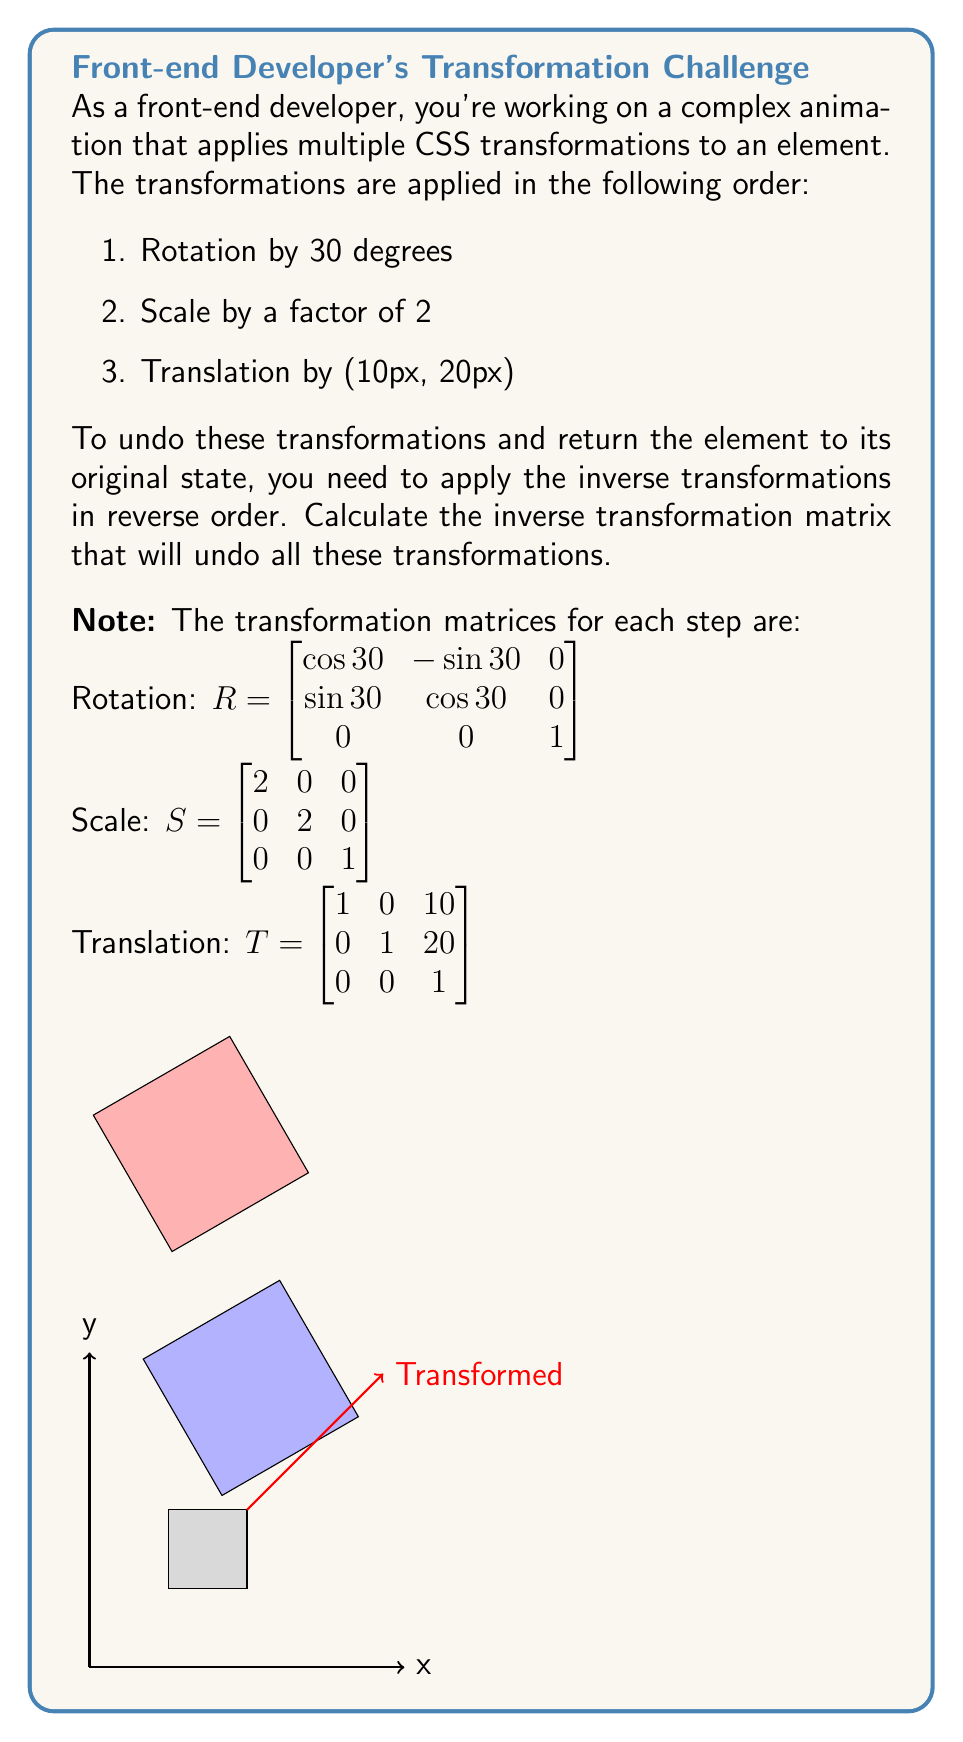Give your solution to this math problem. To solve this problem, we'll follow these steps:

1. Combine the transformation matrices
2. Calculate the inverse of the combined matrix

Step 1: Combine the transformation matrices

The combined transformation matrix is the product of the individual matrices in the order they were applied:

$$M = T \cdot S \cdot R$$

Let's calculate this step by step:

First, multiply S and R:

$$S \cdot R = \begin{bmatrix} 2 & 0 & 0 \\ 0 & 2 & 0 \\ 0 & 0 & 1 \end{bmatrix} \cdot \begin{bmatrix} \cos 30° & -\sin 30° & 0 \\ \sin 30° & \cos 30° & 0 \\ 0 & 0 & 1 \end{bmatrix}$$

$$= \begin{bmatrix} 2\cos 30° & -2\sin 30° & 0 \\ 2\sin 30° & 2\cos 30° & 0 \\ 0 & 0 & 1 \end{bmatrix}$$

Now, multiply T with the result:

$$M = T \cdot (S \cdot R) = \begin{bmatrix} 1 & 0 & 10 \\ 0 & 1 & 20 \\ 0 & 0 & 1 \end{bmatrix} \cdot \begin{bmatrix} 2\cos 30° & -2\sin 30° & 0 \\ 2\sin 30° & 2\cos 30° & 0 \\ 0 & 0 & 1 \end{bmatrix}$$

$$= \begin{bmatrix} 2\cos 30° & -2\sin 30° & 10 \\ 2\sin 30° & 2\cos 30° & 20 \\ 0 & 0 & 1 \end{bmatrix}$$

Step 2: Calculate the inverse of the combined matrix

To undo the transformations, we need to calculate $M^{-1}$. The inverse of a 3x3 matrix can be calculated using the adjugate method:

$$M^{-1} = \frac{1}{det(M)} \cdot adj(M)$$

Where $det(M)$ is the determinant of M and $adj(M)$ is the adjugate of M.

Calculating the determinant:

$$det(M) = 2\cos 30° \cdot 2\cos 30° \cdot 1 + (-2\sin 30°) \cdot 2\sin 30° \cdot 0 + 10 \cdot 20 \cdot 0 - 10 \cdot 2\cos 30° \cdot 0 - (-2\sin 30°) \cdot 20 \cdot 0 - 2\cos 30° \cdot 2\sin 30° \cdot 1$$

$$= 4\cos^2 30° - 4\sin^2 30° = 4(\cos^2 30° - \sin^2 30°) = 4 \cdot \frac{\sqrt{3}}{2} = 2\sqrt{3}$$

Now, let's calculate the adjugate matrix:

$$adj(M) = \begin{bmatrix} 
2\cos 30° & -2\sin 30° & -10\cos 30° + 20\sin 30° \\
2\sin 30° & 2\cos 30° & -10\sin 30° - 20\cos 30° \\
0 & 0 & 4\cos^2 30° + 4\sin^2 30°
\end{bmatrix}$$

Finally, we can calculate the inverse matrix:

$$M^{-1} = \frac{1}{2\sqrt{3}} \cdot \begin{bmatrix} 
2\cos 30° & -2\sin 30° & -10\cos 30° + 20\sin 30° \\
2\sin 30° & 2\cos 30° & -10\sin 30° - 20\cos 30° \\
0 & 0 & 4\cos^2 30° + 4\sin^2 30°
\end{bmatrix}$$

$$= \begin{bmatrix} 
\frac{\cos 30°}{\sqrt{3}} & -\frac{\sin 30°}{\sqrt{3}} & \frac{-5\cos 30° + 10\sin 30°}{\sqrt{3}} \\
\frac{\sin 30°}{\sqrt{3}} & \frac{\cos 30°}{\sqrt{3}} & \frac{-5\sin 30° - 10\cos 30°}{\sqrt{3}} \\
0 & 0 & \frac{1}{2}
\end{bmatrix}$$

This inverse matrix represents the transformation that will undo all the applied transformations and return the element to its original state.
Answer: $$M^{-1} = \begin{bmatrix} 
\frac{\cos 30°}{\sqrt{3}} & -\frac{\sin 30°}{\sqrt{3}} & \frac{-5\cos 30° + 10\sin 30°}{\sqrt{3}} \\
\frac{\sin 30°}{\sqrt{3}} & \frac{\cos 30°}{\sqrt{3}} & \frac{-5\sin 30° - 10\cos 30°}{\sqrt{3}} \\
0 & 0 & \frac{1}{2}
\end{bmatrix}$$ 